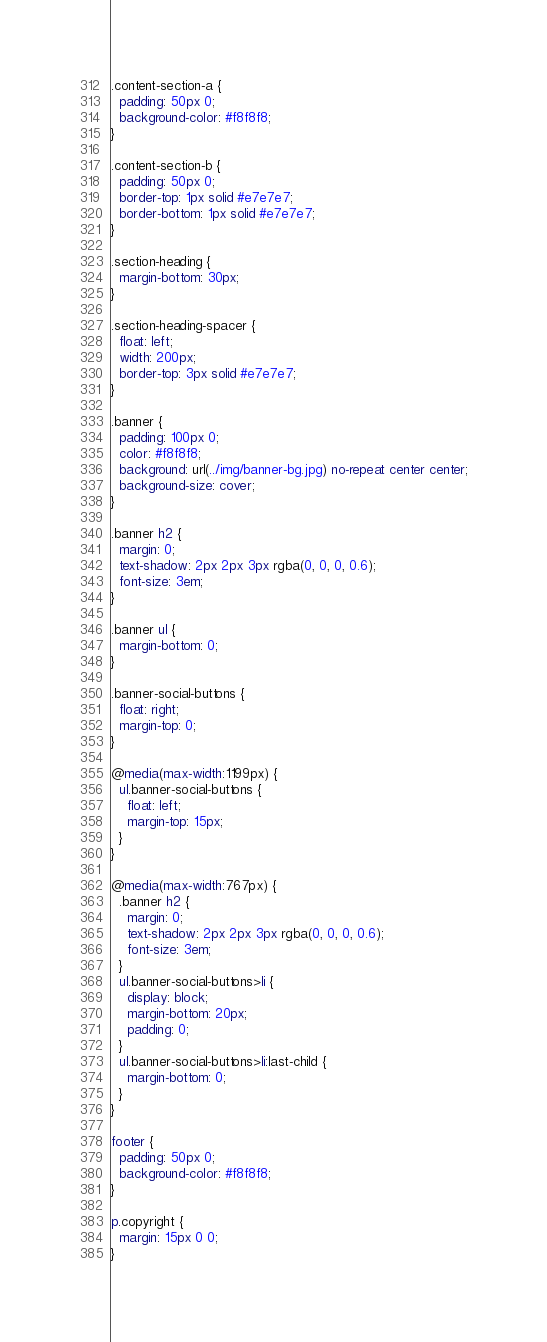Convert code to text. <code><loc_0><loc_0><loc_500><loc_500><_CSS_>.content-section-a {
  padding: 50px 0;
  background-color: #f8f8f8;
}

.content-section-b {
  padding: 50px 0;
  border-top: 1px solid #e7e7e7;
  border-bottom: 1px solid #e7e7e7;
}

.section-heading {
  margin-bottom: 30px;
}

.section-heading-spacer {
  float: left;
  width: 200px;
  border-top: 3px solid #e7e7e7;
}

.banner {
  padding: 100px 0;
  color: #f8f8f8;
  background: url(../img/banner-bg.jpg) no-repeat center center;
  background-size: cover;
}

.banner h2 {
  margin: 0;
  text-shadow: 2px 2px 3px rgba(0, 0, 0, 0.6);
  font-size: 3em;
}

.banner ul {
  margin-bottom: 0;
}

.banner-social-buttons {
  float: right;
  margin-top: 0;
}

@media(max-width:1199px) {
  ul.banner-social-buttons {
    float: left;
    margin-top: 15px;
  }
}

@media(max-width:767px) {
  .banner h2 {
    margin: 0;
    text-shadow: 2px 2px 3px rgba(0, 0, 0, 0.6);
    font-size: 3em;
  }
  ul.banner-social-buttons>li {
    display: block;
    margin-bottom: 20px;
    padding: 0;
  }
  ul.banner-social-buttons>li:last-child {
    margin-bottom: 0;
  }
}

footer {
  padding: 50px 0;
  background-color: #f8f8f8;
}

p.copyright {
  margin: 15px 0 0;
}

</code> 